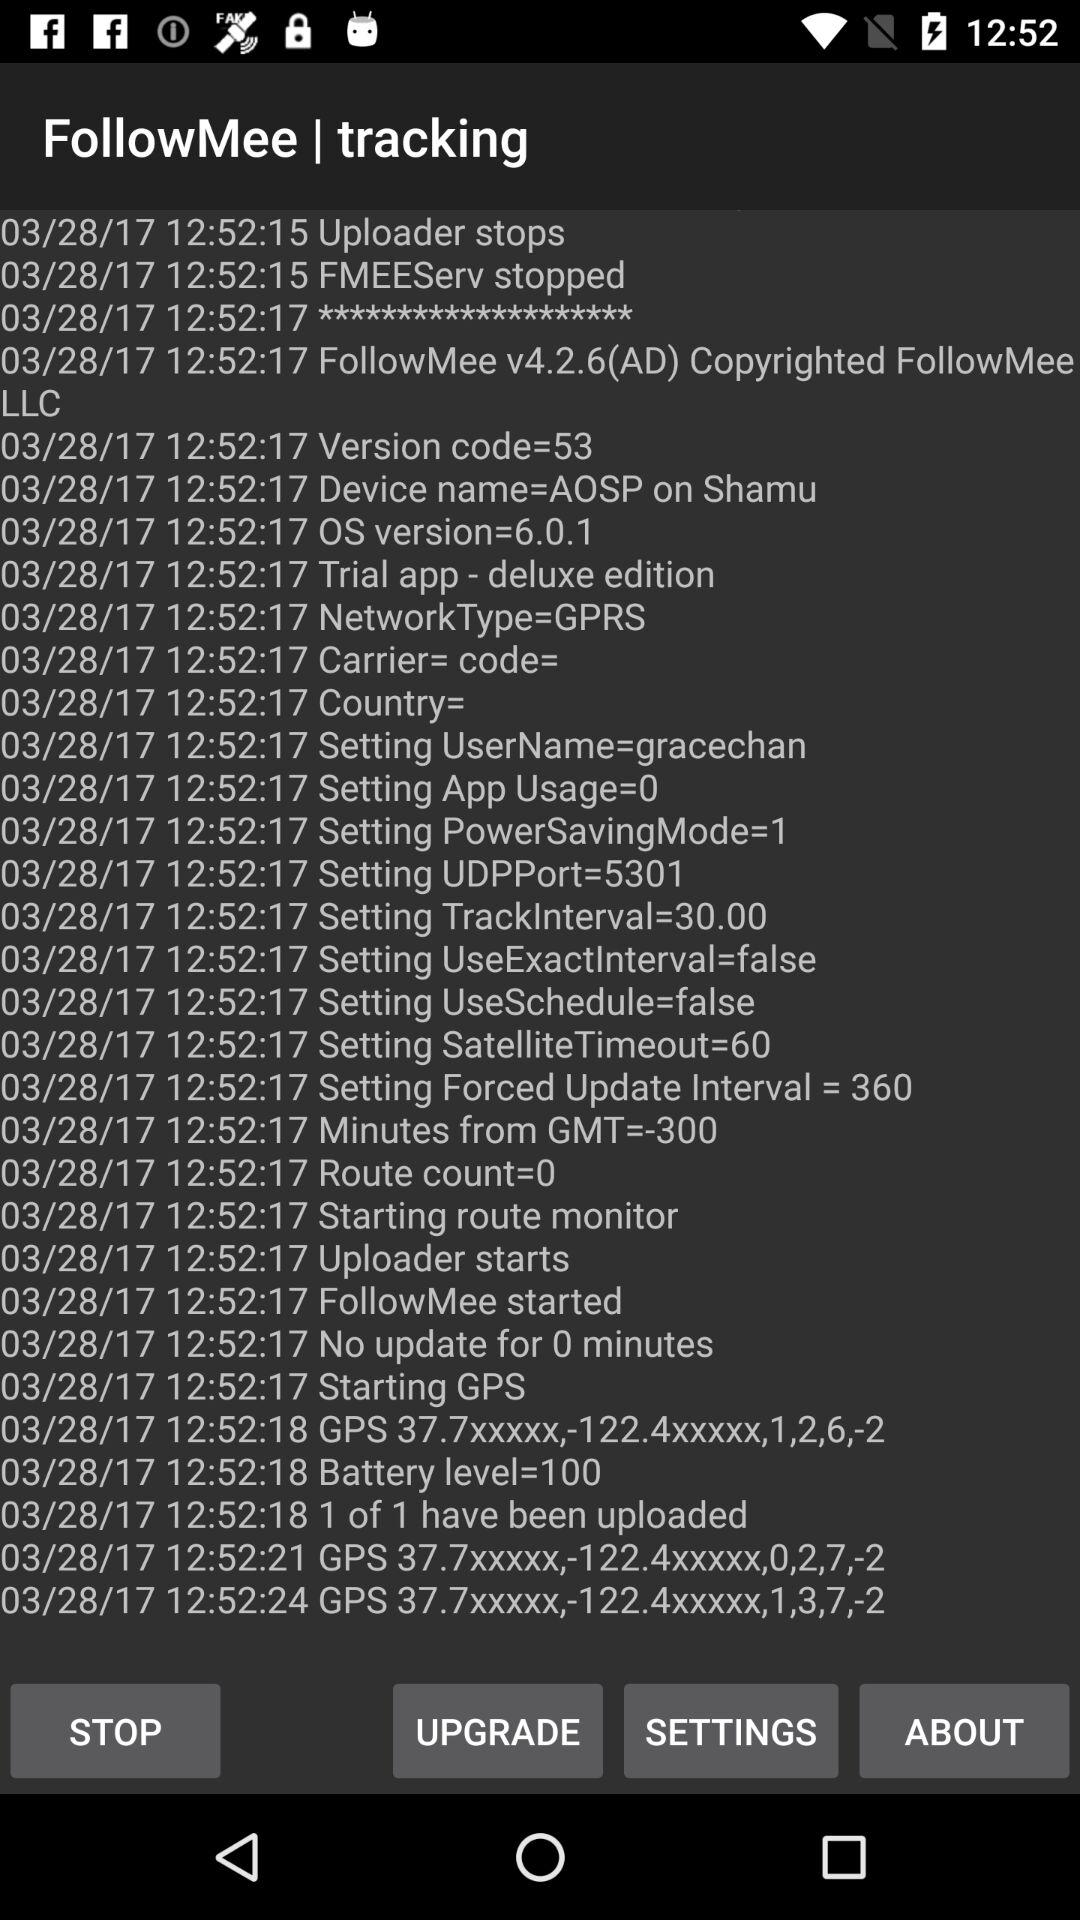How many routes have been uploaded?
Answer the question using a single word or phrase. 1 